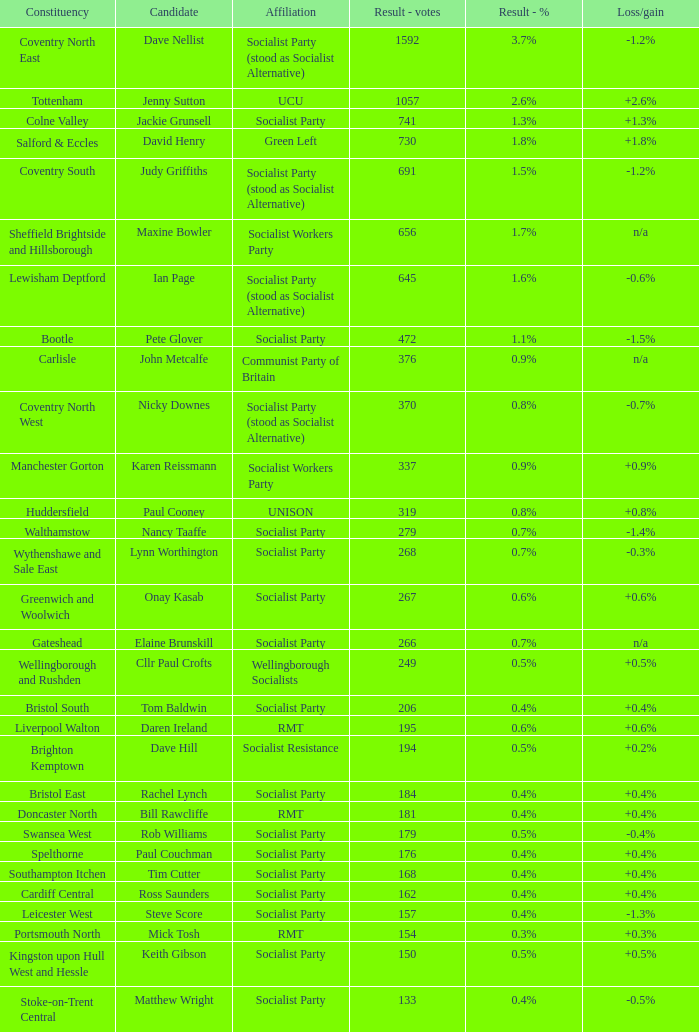What are all associations for candidate daren ireland? RMT. 